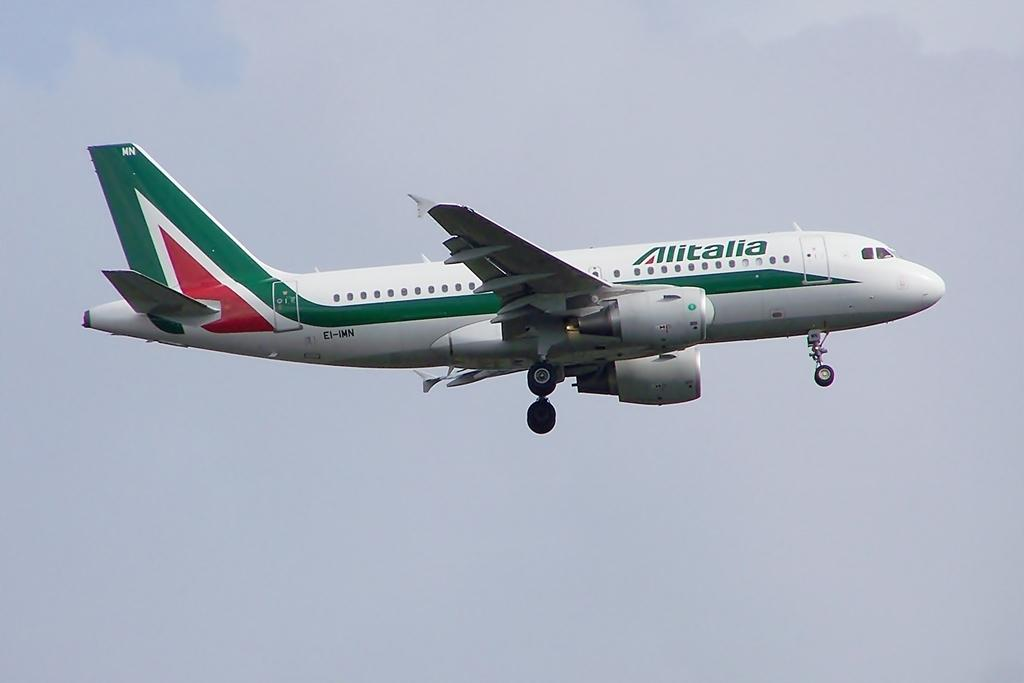Where was the image taken? The image was taken outdoors. What can be seen in the background of the image? There is a sky with clouds visible in the background. What is flying in the sky in the middle of the image? There is an airplane flying in the sky in the middle of the image. What arithmetic problem is being solved by the clouds in the image? The clouds in the image are not solving any arithmetic problem; they are simply part of the natural background. 